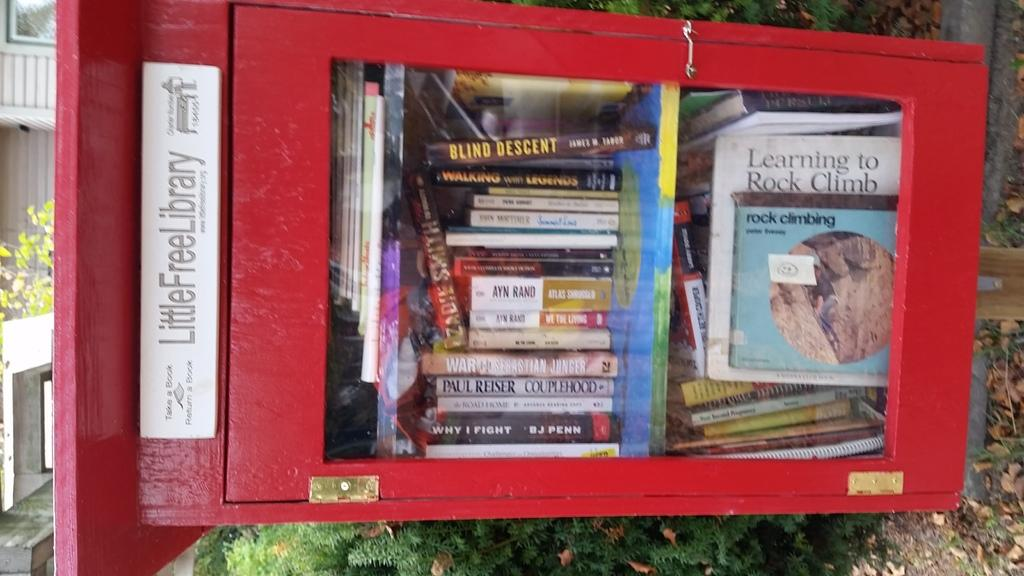<image>
Describe the image concisely. A red newspaper box filled with books like The Blind Descent and Learning to Rock Climb. 